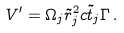Convert formula to latex. <formula><loc_0><loc_0><loc_500><loc_500>V ^ { \prime } = \Omega _ { j } \tilde { r } _ { j } ^ { 2 } c \tilde { t } _ { j } \Gamma \, .</formula> 